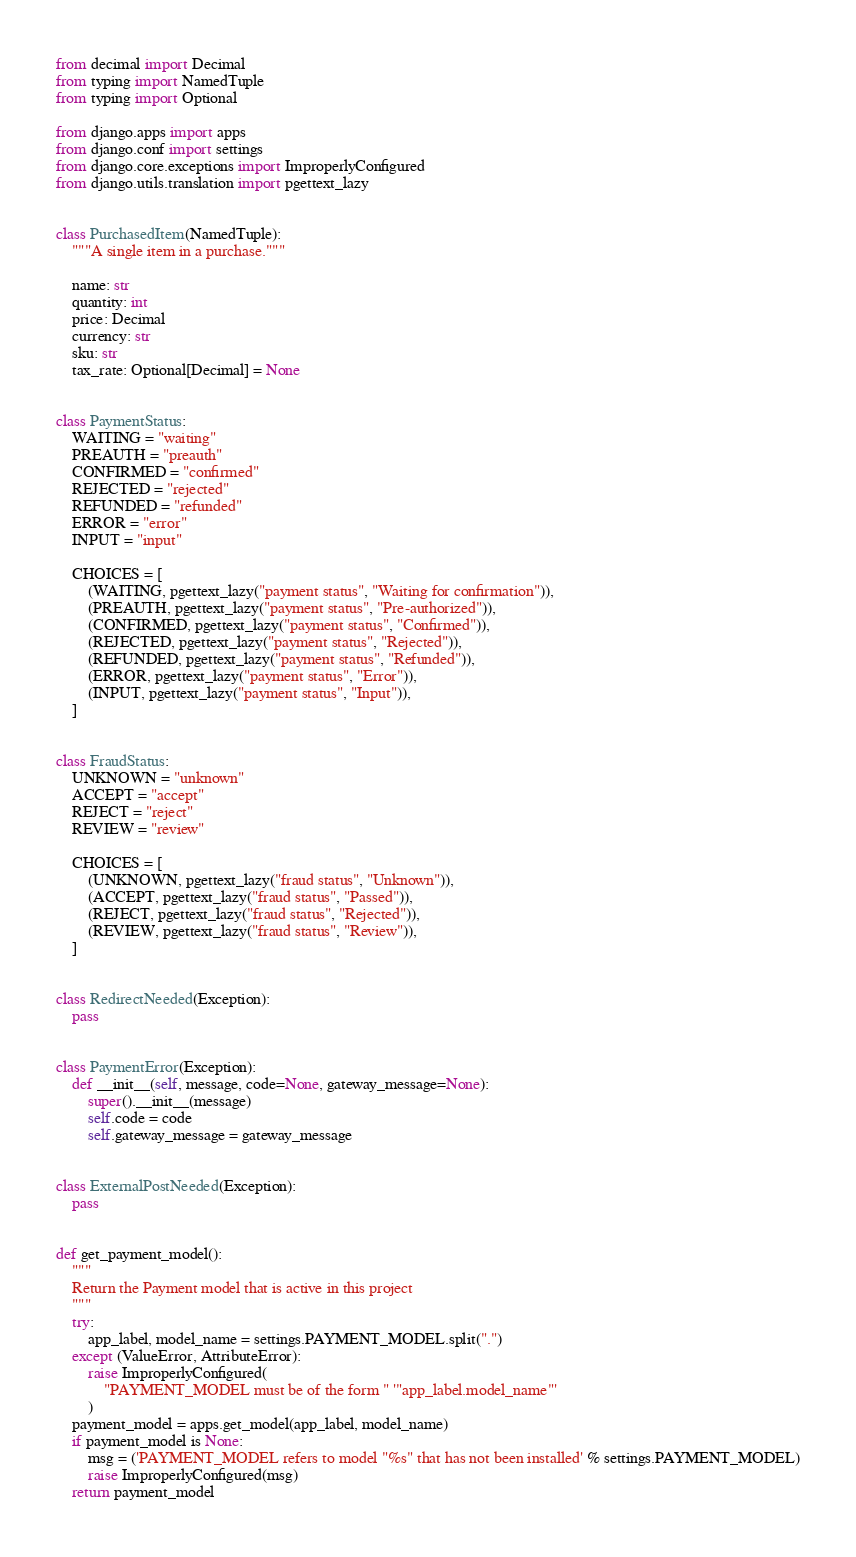<code> <loc_0><loc_0><loc_500><loc_500><_Python_>from decimal import Decimal
from typing import NamedTuple
from typing import Optional

from django.apps import apps
from django.conf import settings
from django.core.exceptions import ImproperlyConfigured
from django.utils.translation import pgettext_lazy


class PurchasedItem(NamedTuple):
    """A single item in a purchase."""

    name: str
    quantity: int
    price: Decimal
    currency: str
    sku: str
    tax_rate: Optional[Decimal] = None


class PaymentStatus:
    WAITING = "waiting"
    PREAUTH = "preauth"
    CONFIRMED = "confirmed"
    REJECTED = "rejected"
    REFUNDED = "refunded"
    ERROR = "error"
    INPUT = "input"

    CHOICES = [
        (WAITING, pgettext_lazy("payment status", "Waiting for confirmation")),
        (PREAUTH, pgettext_lazy("payment status", "Pre-authorized")),
        (CONFIRMED, pgettext_lazy("payment status", "Confirmed")),
        (REJECTED, pgettext_lazy("payment status", "Rejected")),
        (REFUNDED, pgettext_lazy("payment status", "Refunded")),
        (ERROR, pgettext_lazy("payment status", "Error")),
        (INPUT, pgettext_lazy("payment status", "Input")),
    ]


class FraudStatus:
    UNKNOWN = "unknown"
    ACCEPT = "accept"
    REJECT = "reject"
    REVIEW = "review"

    CHOICES = [
        (UNKNOWN, pgettext_lazy("fraud status", "Unknown")),
        (ACCEPT, pgettext_lazy("fraud status", "Passed")),
        (REJECT, pgettext_lazy("fraud status", "Rejected")),
        (REVIEW, pgettext_lazy("fraud status", "Review")),
    ]


class RedirectNeeded(Exception):
    pass


class PaymentError(Exception):
    def __init__(self, message, code=None, gateway_message=None):
        super().__init__(message)
        self.code = code
        self.gateway_message = gateway_message


class ExternalPostNeeded(Exception):
    pass


def get_payment_model():
    """
    Return the Payment model that is active in this project
    """
    try:
        app_label, model_name = settings.PAYMENT_MODEL.split(".")
    except (ValueError, AttributeError):
        raise ImproperlyConfigured(
            "PAYMENT_MODEL must be of the form " '"app_label.model_name"'
        )
    payment_model = apps.get_model(app_label, model_name)
    if payment_model is None:
        msg = ('PAYMENT_MODEL refers to model "%s" that has not been installed' % settings.PAYMENT_MODEL)
        raise ImproperlyConfigured(msg)
    return payment_model
</code> 